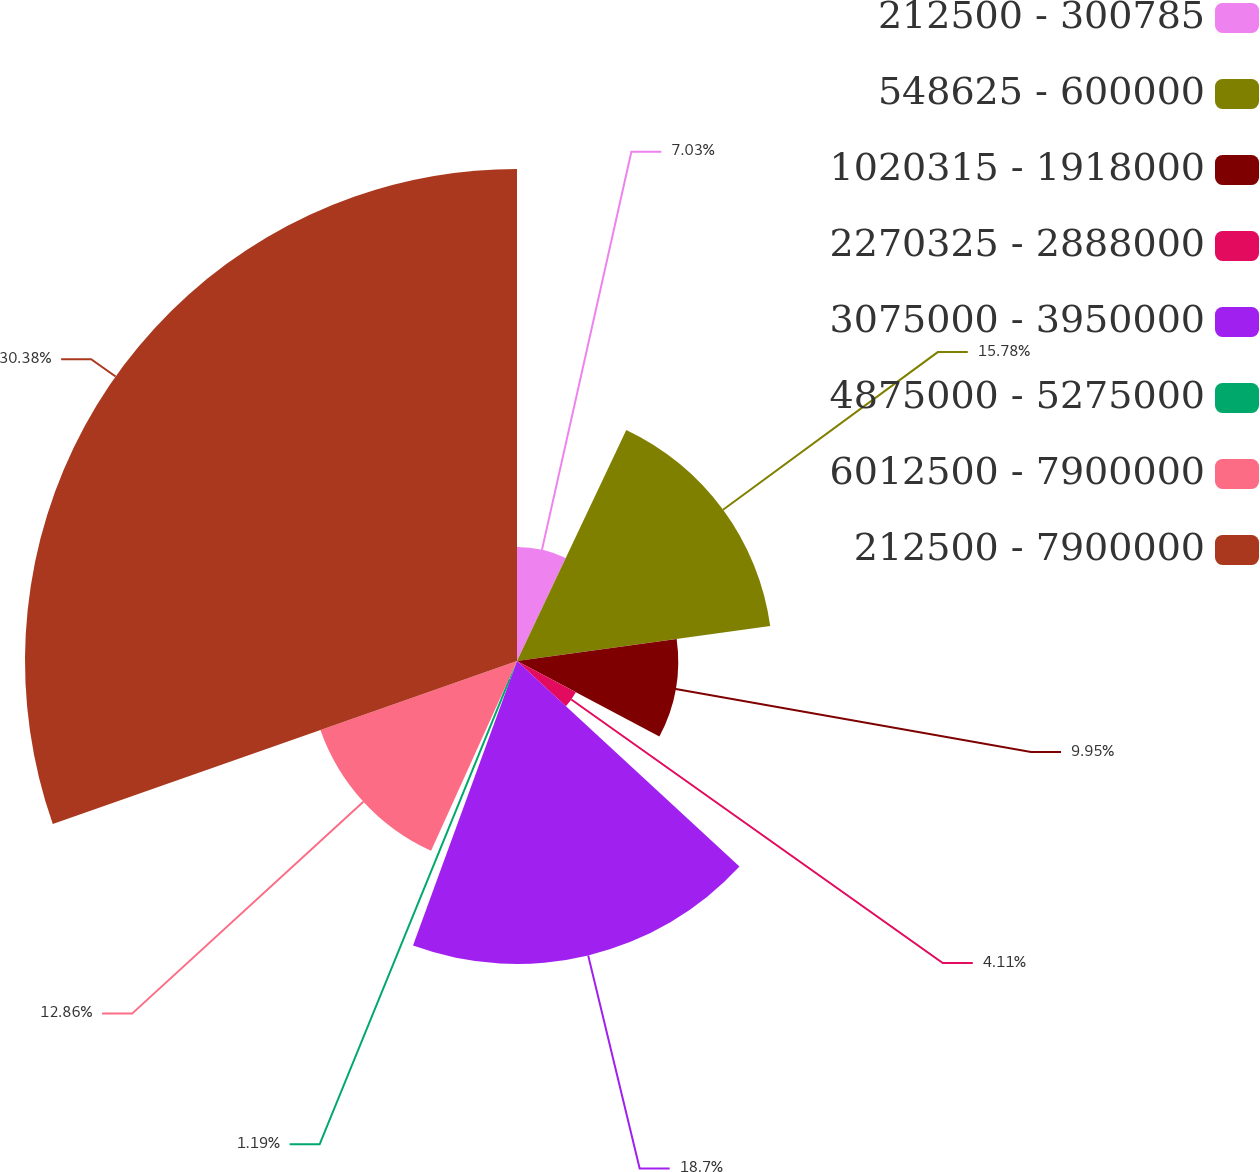Convert chart to OTSL. <chart><loc_0><loc_0><loc_500><loc_500><pie_chart><fcel>212500 - 300785<fcel>548625 - 600000<fcel>1020315 - 1918000<fcel>2270325 - 2888000<fcel>3075000 - 3950000<fcel>4875000 - 5275000<fcel>6012500 - 7900000<fcel>212500 - 7900000<nl><fcel>7.03%<fcel>15.78%<fcel>9.95%<fcel>4.11%<fcel>18.7%<fcel>1.19%<fcel>12.86%<fcel>30.37%<nl></chart> 